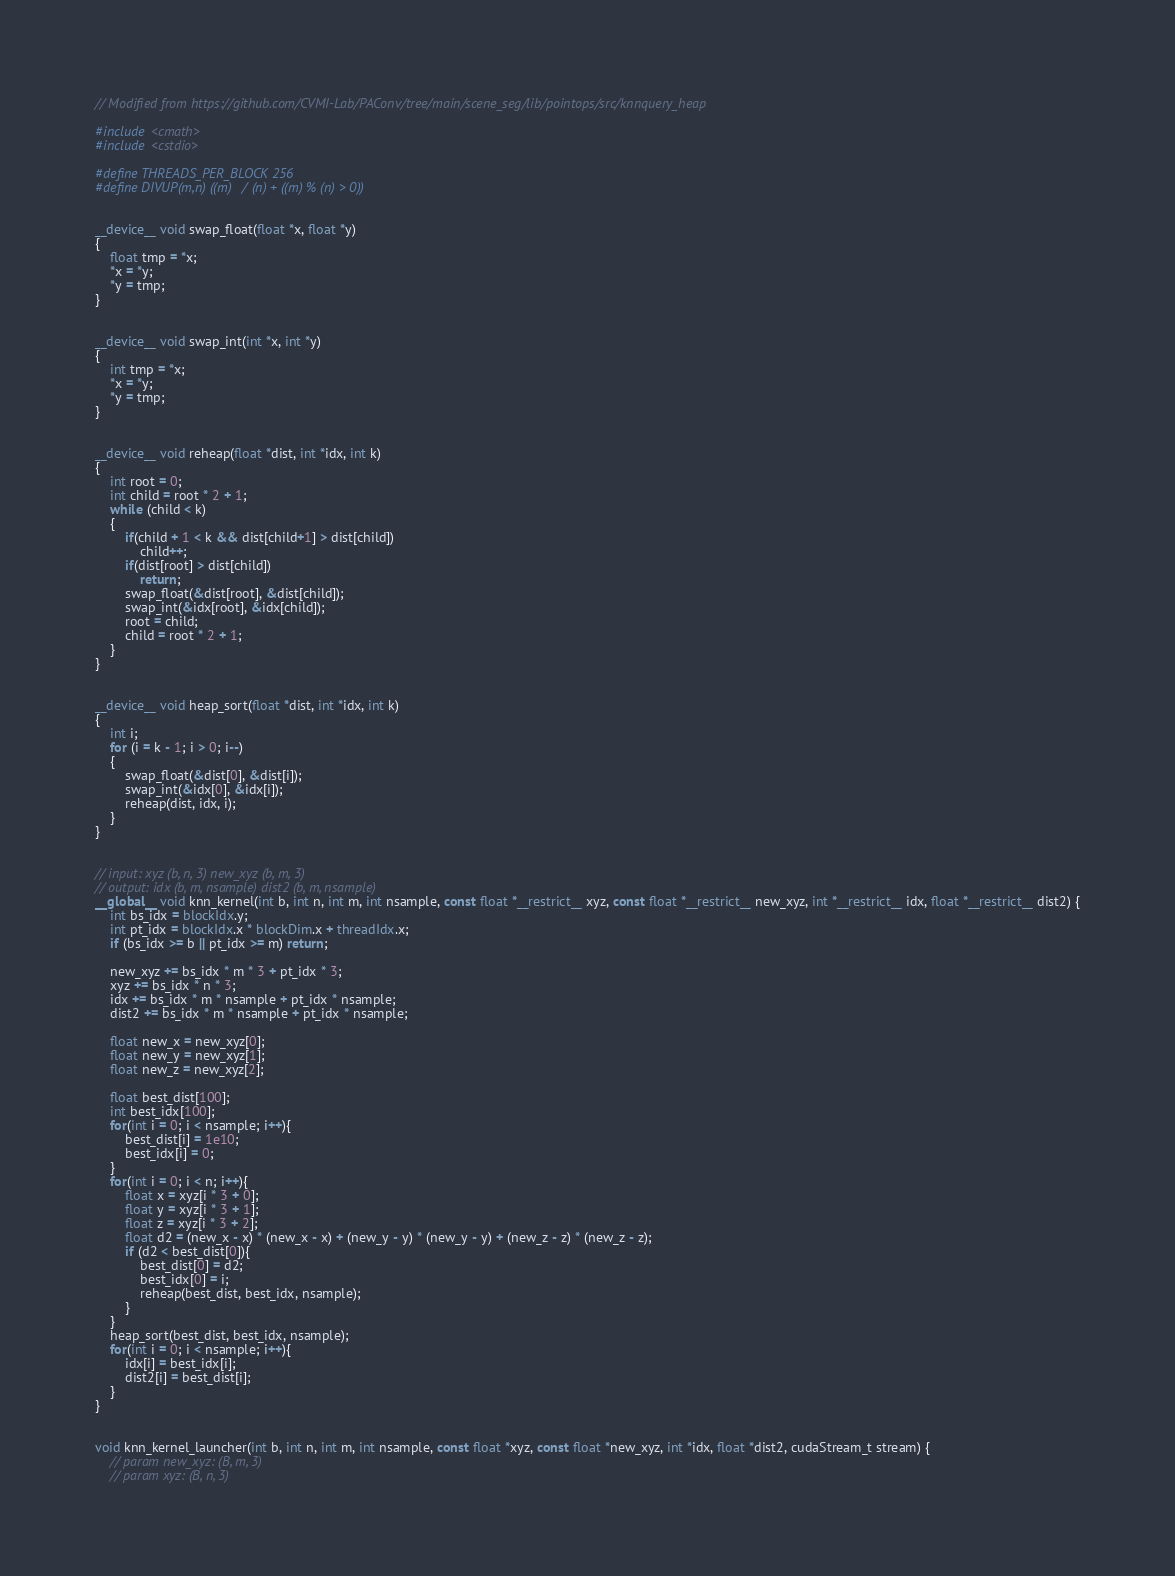<code> <loc_0><loc_0><loc_500><loc_500><_Cuda_>// Modified from https://github.com/CVMI-Lab/PAConv/tree/main/scene_seg/lib/pointops/src/knnquery_heap

#include <cmath>
#include <cstdio>

#define THREADS_PER_BLOCK 256
#define DIVUP(m,n) ((m) / (n) + ((m) % (n) > 0))


__device__ void swap_float(float *x, float *y)
{
    float tmp = *x;
    *x = *y;
    *y = tmp;
}


__device__ void swap_int(int *x, int *y)
{
    int tmp = *x;
    *x = *y;
    *y = tmp;
}


__device__ void reheap(float *dist, int *idx, int k)
{
    int root = 0;
    int child = root * 2 + 1;
    while (child < k)
    {
        if(child + 1 < k && dist[child+1] > dist[child])
            child++;
        if(dist[root] > dist[child])
            return;
        swap_float(&dist[root], &dist[child]);
        swap_int(&idx[root], &idx[child]);
        root = child;
        child = root * 2 + 1;
    }
}


__device__ void heap_sort(float *dist, int *idx, int k)
{
    int i;
    for (i = k - 1; i > 0; i--)
    {
        swap_float(&dist[0], &dist[i]);
        swap_int(&idx[0], &idx[i]);
        reheap(dist, idx, i);
    }
}


// input: xyz (b, n, 3) new_xyz (b, m, 3)
// output: idx (b, m, nsample) dist2 (b, m, nsample)
__global__ void knn_kernel(int b, int n, int m, int nsample, const float *__restrict__ xyz, const float *__restrict__ new_xyz, int *__restrict__ idx, float *__restrict__ dist2) {
    int bs_idx = blockIdx.y;
    int pt_idx = blockIdx.x * blockDim.x + threadIdx.x;
    if (bs_idx >= b || pt_idx >= m) return;

    new_xyz += bs_idx * m * 3 + pt_idx * 3;
    xyz += bs_idx * n * 3;
    idx += bs_idx * m * nsample + pt_idx * nsample;
    dist2 += bs_idx * m * nsample + pt_idx * nsample;

    float new_x = new_xyz[0];
    float new_y = new_xyz[1];
    float new_z = new_xyz[2];

    float best_dist[100];
    int best_idx[100];
    for(int i = 0; i < nsample; i++){
        best_dist[i] = 1e10;
        best_idx[i] = 0;
    }
    for(int i = 0; i < n; i++){
        float x = xyz[i * 3 + 0];
        float y = xyz[i * 3 + 1];
        float z = xyz[i * 3 + 2];
        float d2 = (new_x - x) * (new_x - x) + (new_y - y) * (new_y - y) + (new_z - z) * (new_z - z);
        if (d2 < best_dist[0]){
            best_dist[0] = d2;
            best_idx[0] = i;
            reheap(best_dist, best_idx, nsample);
        }
    }
    heap_sort(best_dist, best_idx, nsample);
    for(int i = 0; i < nsample; i++){
        idx[i] = best_idx[i];
        dist2[i] = best_dist[i];
    }
}


void knn_kernel_launcher(int b, int n, int m, int nsample, const float *xyz, const float *new_xyz, int *idx, float *dist2, cudaStream_t stream) {
    // param new_xyz: (B, m, 3)
    // param xyz: (B, n, 3)</code> 